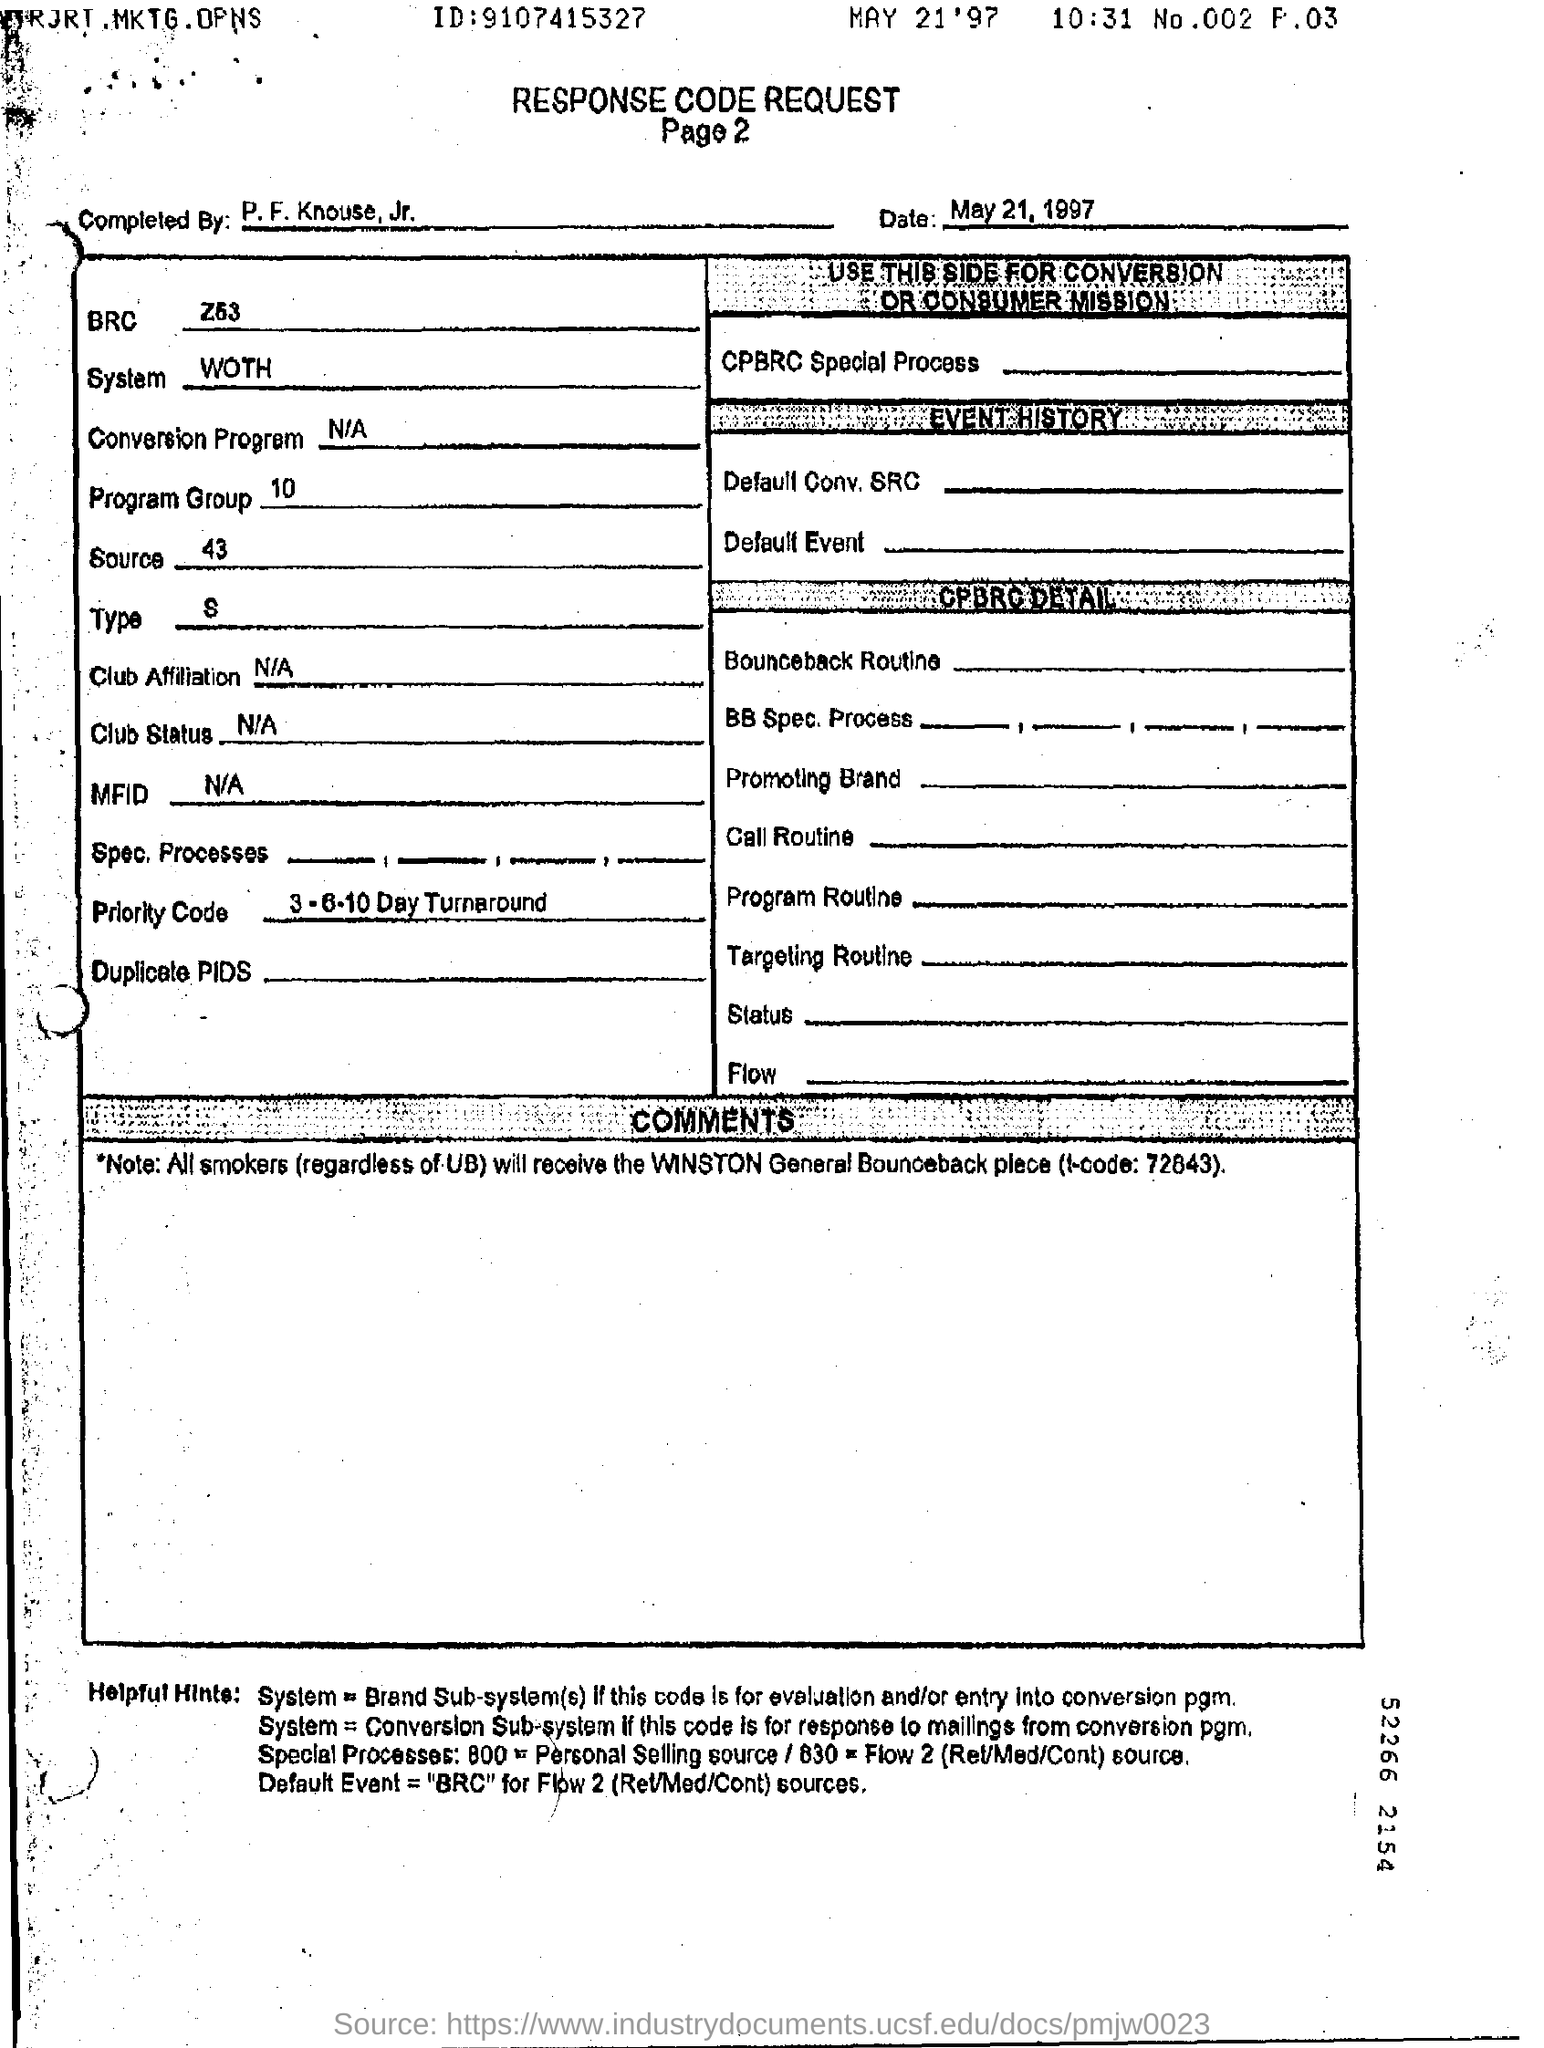Mention a couple of crucial points in this snapshot. Please provide a response code for the document regarding its content. The date given is May 21, 1997. A priority code of 3-6 has been assigned to the order, with a 10-day turnaround time required. A unique identification number, 9107415327, has been assigned to... The system being presented is... 